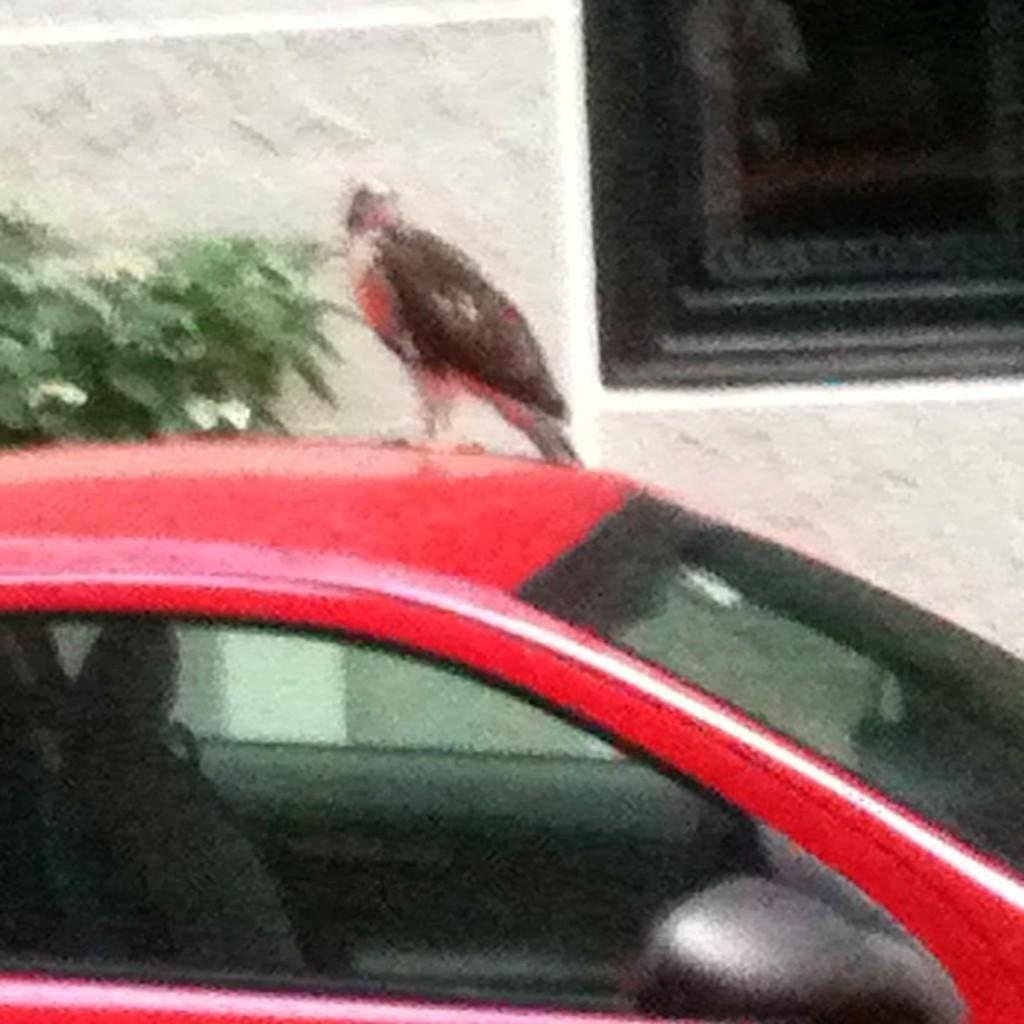Could you give a brief overview of what you see in this image? In this image I can see a bird on a red color car. Behind the car there is a plant. In the background there is a window to the wall. 